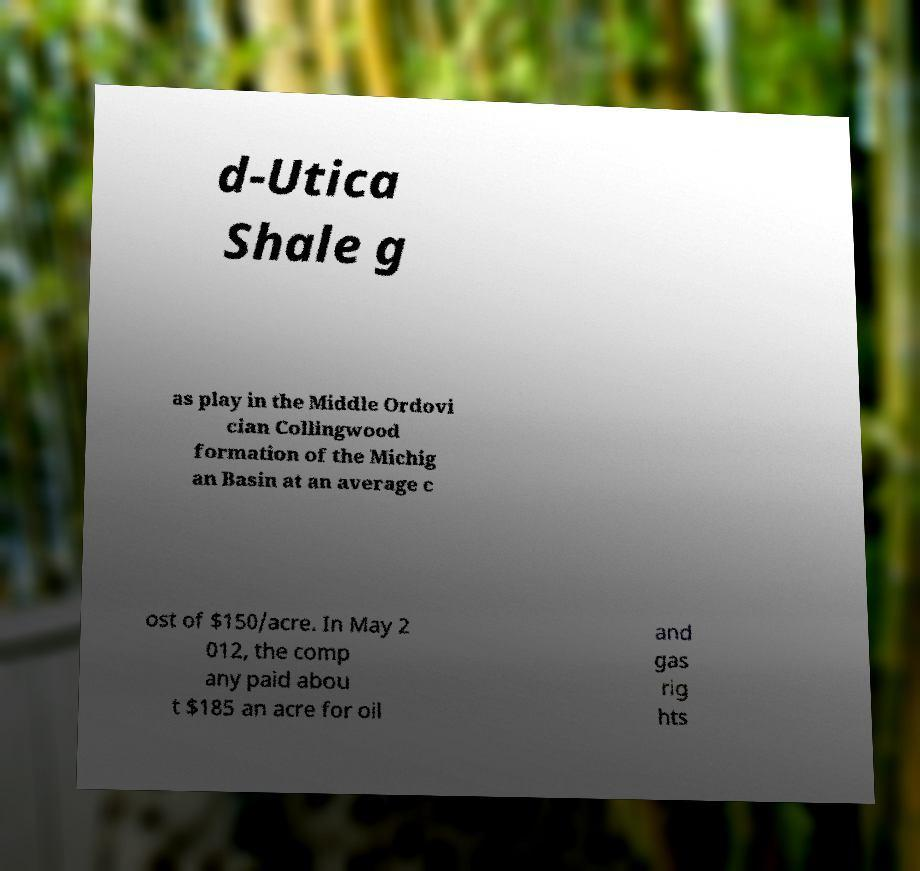What messages or text are displayed in this image? I need them in a readable, typed format. d-Utica Shale g as play in the Middle Ordovi cian Collingwood formation of the Michig an Basin at an average c ost of $150/acre. In May 2 012, the comp any paid abou t $185 an acre for oil and gas rig hts 